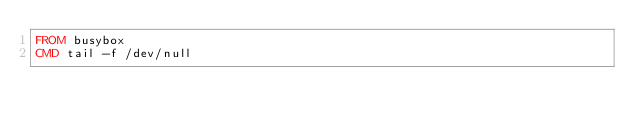<code> <loc_0><loc_0><loc_500><loc_500><_Dockerfile_>FROM busybox
CMD tail -f /dev/null
</code> 